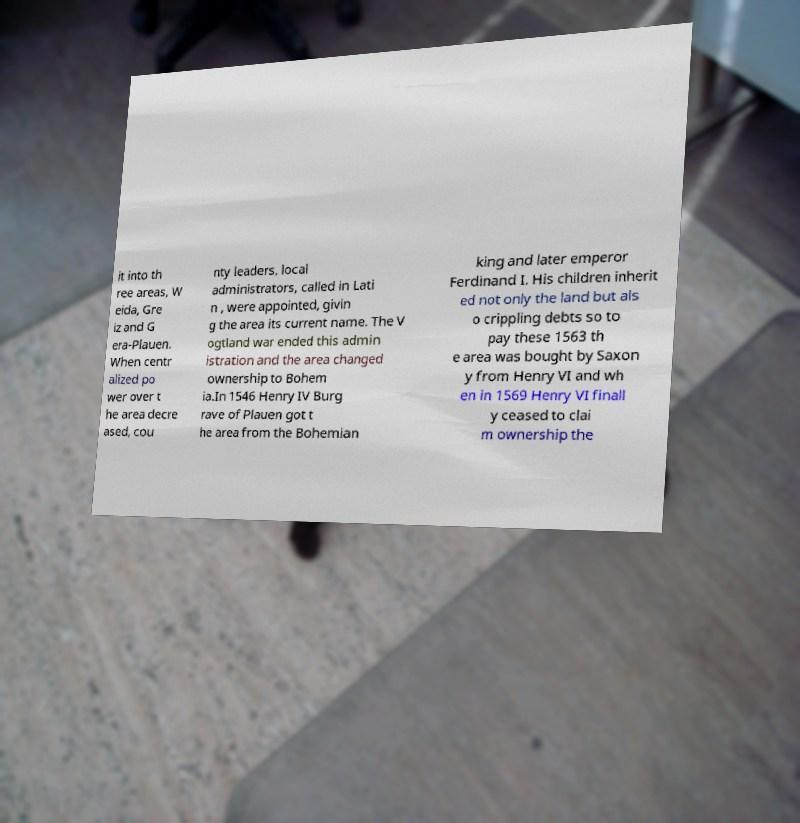Can you read and provide the text displayed in the image?This photo seems to have some interesting text. Can you extract and type it out for me? it into th ree areas, W eida, Gre iz and G era-Plauen. When centr alized po wer over t he area decre ased, cou nty leaders, local administrators, called in Lati n , were appointed, givin g the area its current name. The V ogtland war ended this admin istration and the area changed ownership to Bohem ia.In 1546 Henry IV Burg rave of Plauen got t he area from the Bohemian king and later emperor Ferdinand I. His children inherit ed not only the land but als o crippling debts so to pay these 1563 th e area was bought by Saxon y from Henry VI and wh en in 1569 Henry VI finall y ceased to clai m ownership the 